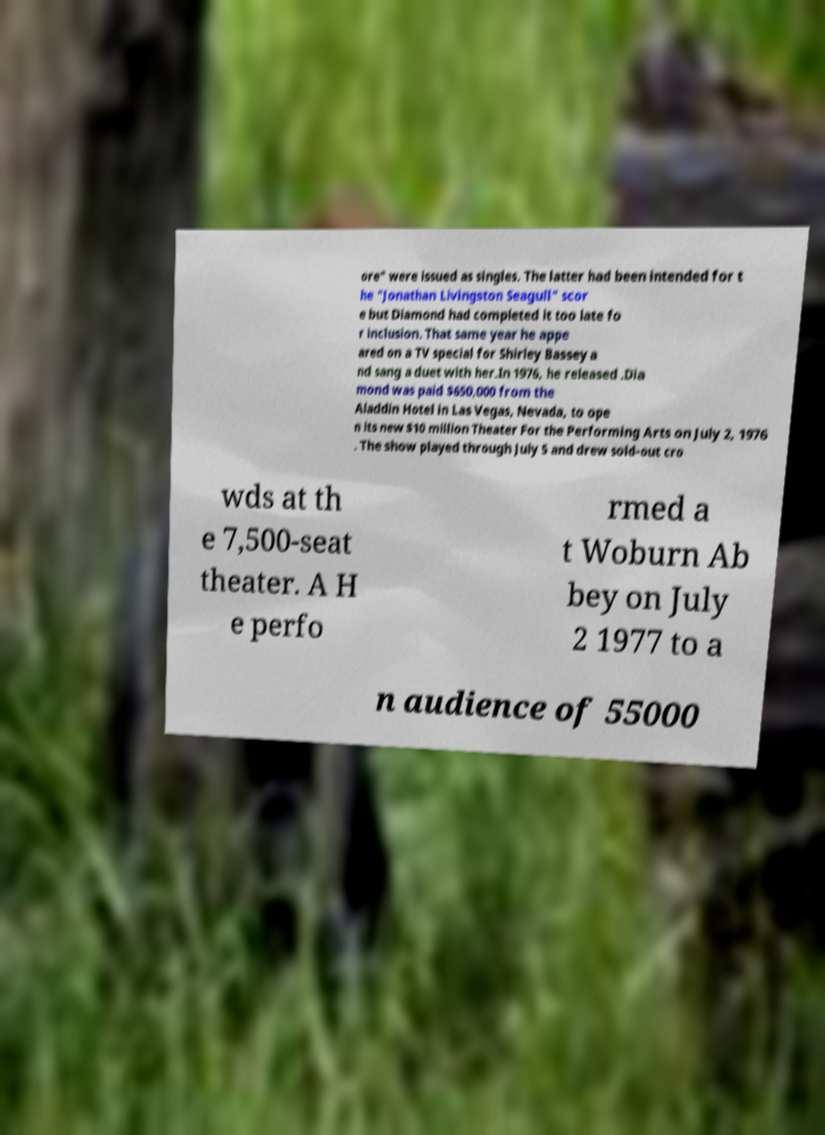Can you read and provide the text displayed in the image?This photo seems to have some interesting text. Can you extract and type it out for me? ore" were issued as singles. The latter had been intended for t he "Jonathan Livingston Seagull" scor e but Diamond had completed it too late fo r inclusion. That same year he appe ared on a TV special for Shirley Bassey a nd sang a duet with her.In 1976, he released .Dia mond was paid $650,000 from the Aladdin Hotel in Las Vegas, Nevada, to ope n its new $10 million Theater For the Performing Arts on July 2, 1976 . The show played through July 5 and drew sold-out cro wds at th e 7,500-seat theater. A H e perfo rmed a t Woburn Ab bey on July 2 1977 to a n audience of 55000 